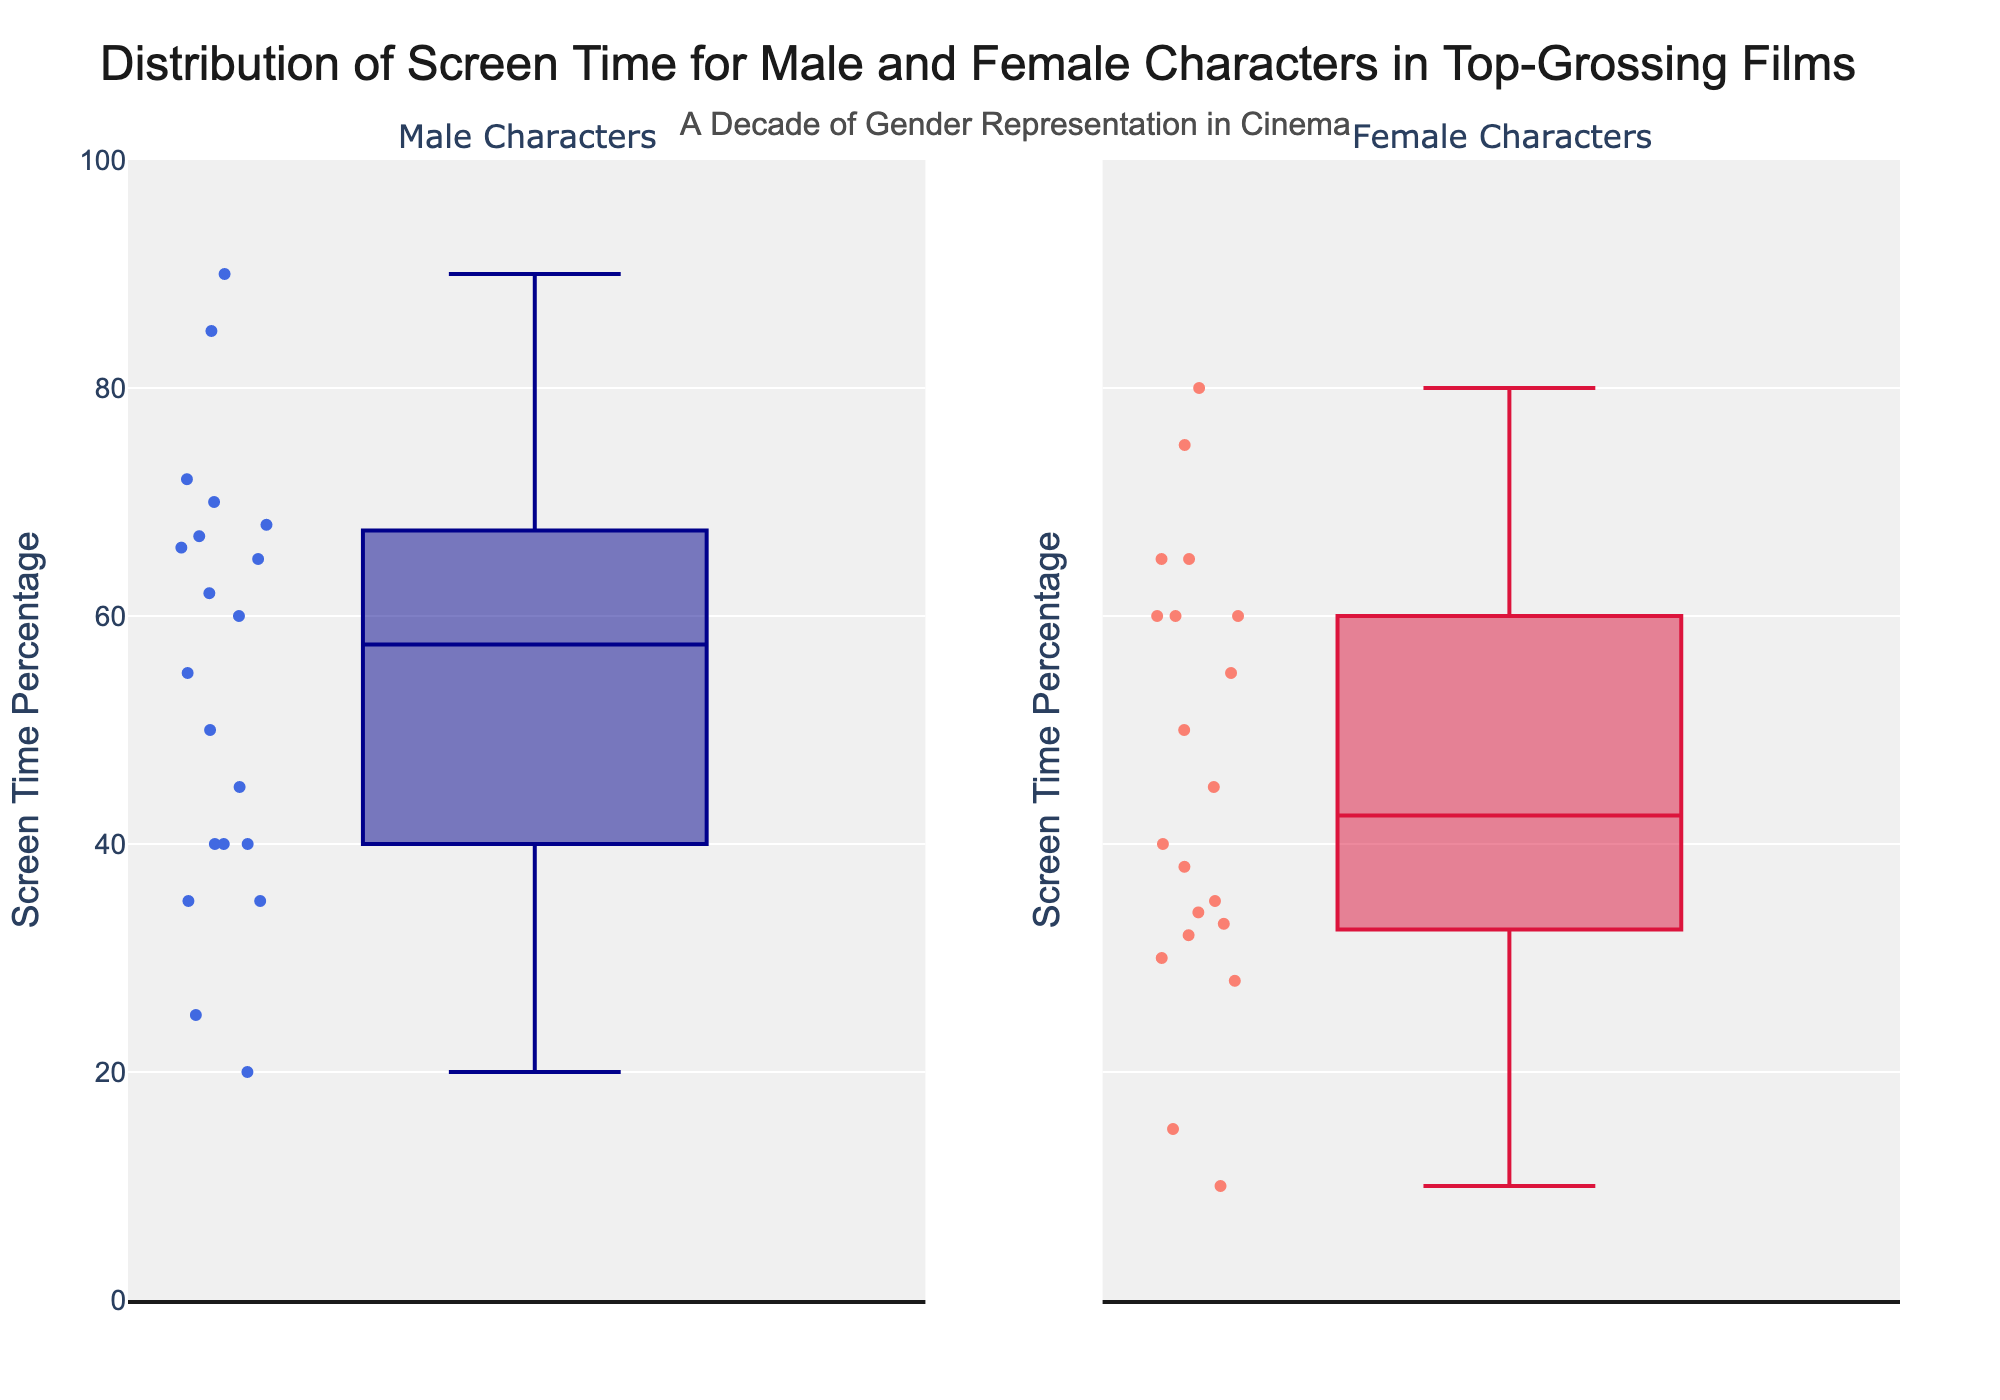What is the title of the plot? The title is typically displayed prominently at the top of the figure, summarizing the main information. In this case, it reads "Distribution of Screen Time for Male and Female Characters in Top-Grossing Films".
Answer: Distribution of Screen Time for Male and Female Characters in Top-Grossing Films What does the y-axis represent? The y-axis label is usually near the y-axis itself, providing a description of what it measures. Here, it indicates "Screen Time Percentage".
Answer: Screen Time Percentage What is the range of the y-axis? The y-axis of the figure ranges from the smallest value at the bottom to the largest value at the top. By observing the axis, we can see that it goes from 0 to 100.
Answer: 0 to 100 What are the median values of screen time for male and female characters? To find the median values, look at the middle line in each box plot. The median for male characters appears around 65, and for female characters, it appears around 50.
Answer: Males: 65, Females: 50 Which gender has a wider range of screen time percentages? The range can be determined by the span between the minimum and maximum whiskers of each box plot. The male characters have a range approximately from 20 to 90, while female characters are from about 10 to 80.
Answer: Males Which gender has the highest outlier in screen time percentage? Outliers are points that lie far away from the main box plot. For males, the top point aligns with 90, which is the highest extreme data point shown in the plot.
Answer: Males Are there any genders with the same median screen time percentage? Median values are represented by the central line within each box. In this case, both genders have different medians.
Answer: No What is the 25th percentile for female characters? The 25th percentile is represented by the bottom edge of the box. For female characters, this value appears to be around 33.
Answer: Approximately 33 How do the interquartile ranges (IQR) of male and female characters compare? The IQR is the difference between the 75th percentile and the 25th percentile. For males, it's from about 50 to 75 (25 units). For females, it's from about 33 to 60 (27 units). Therefore, female characters have a slightly larger IQR.
Answer: Females have a slightly larger IQR Which gender has a lower minimum screen time percentage? The minimum screen time is indicated by the bottom whisker of the box plot. The minimum for female characters is around 10, and for males, it's around 20.
Answer: Females 